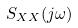Convert formula to latex. <formula><loc_0><loc_0><loc_500><loc_500>S _ { X X } ( j \omega )</formula> 